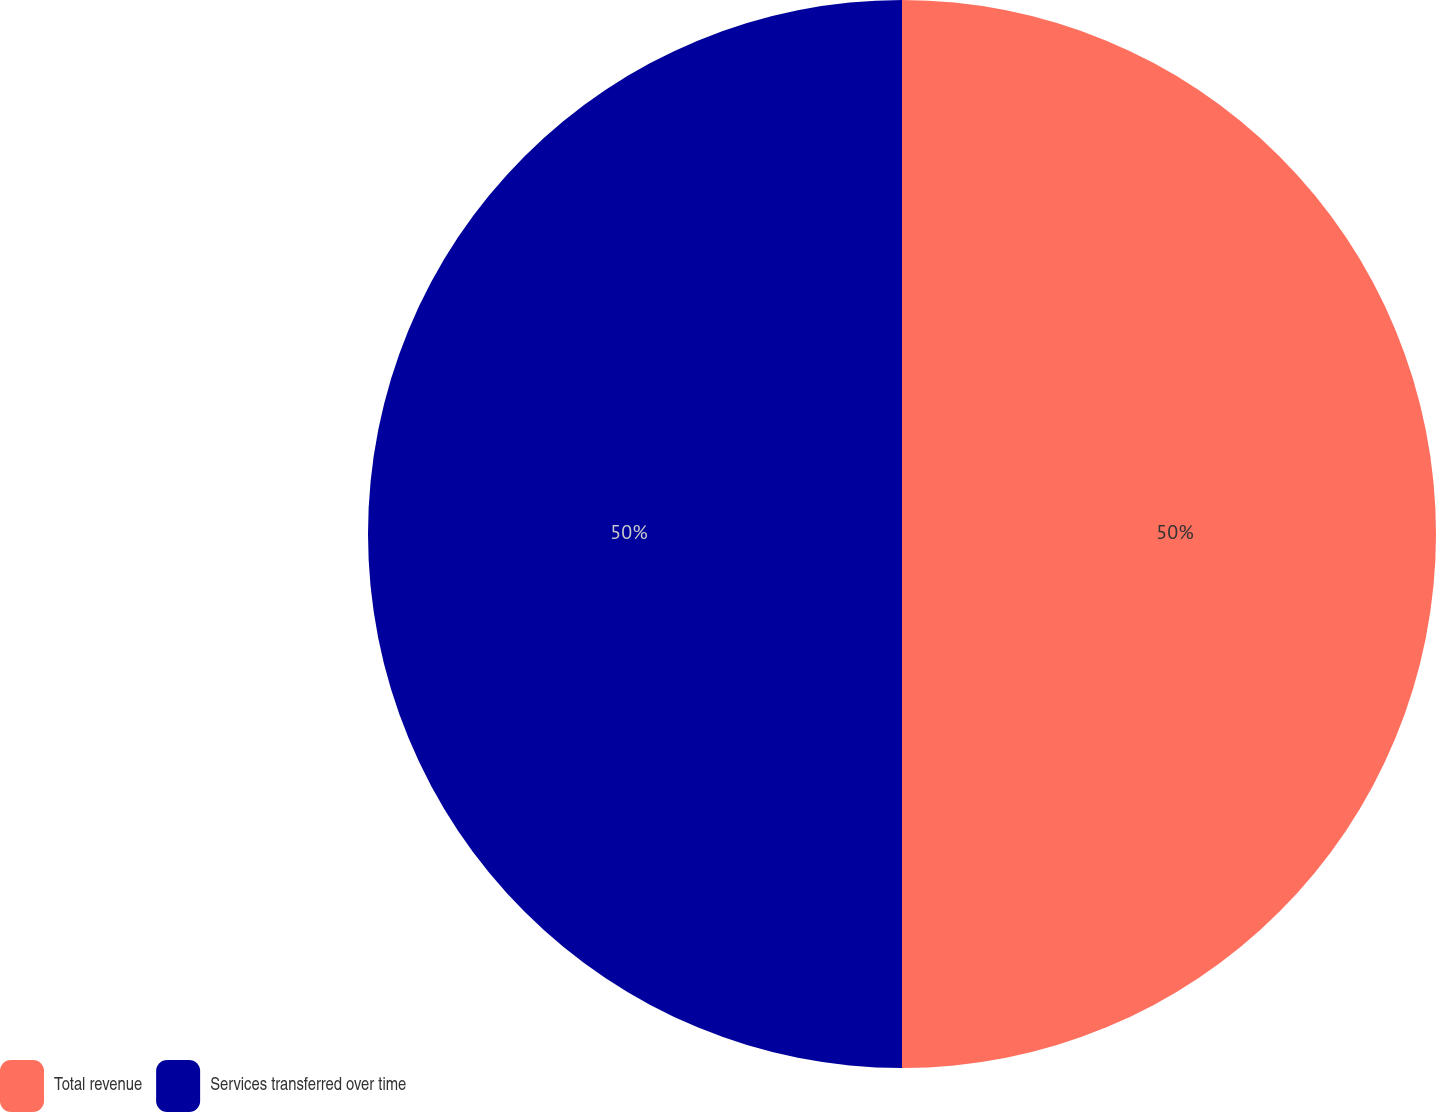<chart> <loc_0><loc_0><loc_500><loc_500><pie_chart><fcel>Total revenue<fcel>Services transferred over time<nl><fcel>50.0%<fcel>50.0%<nl></chart> 